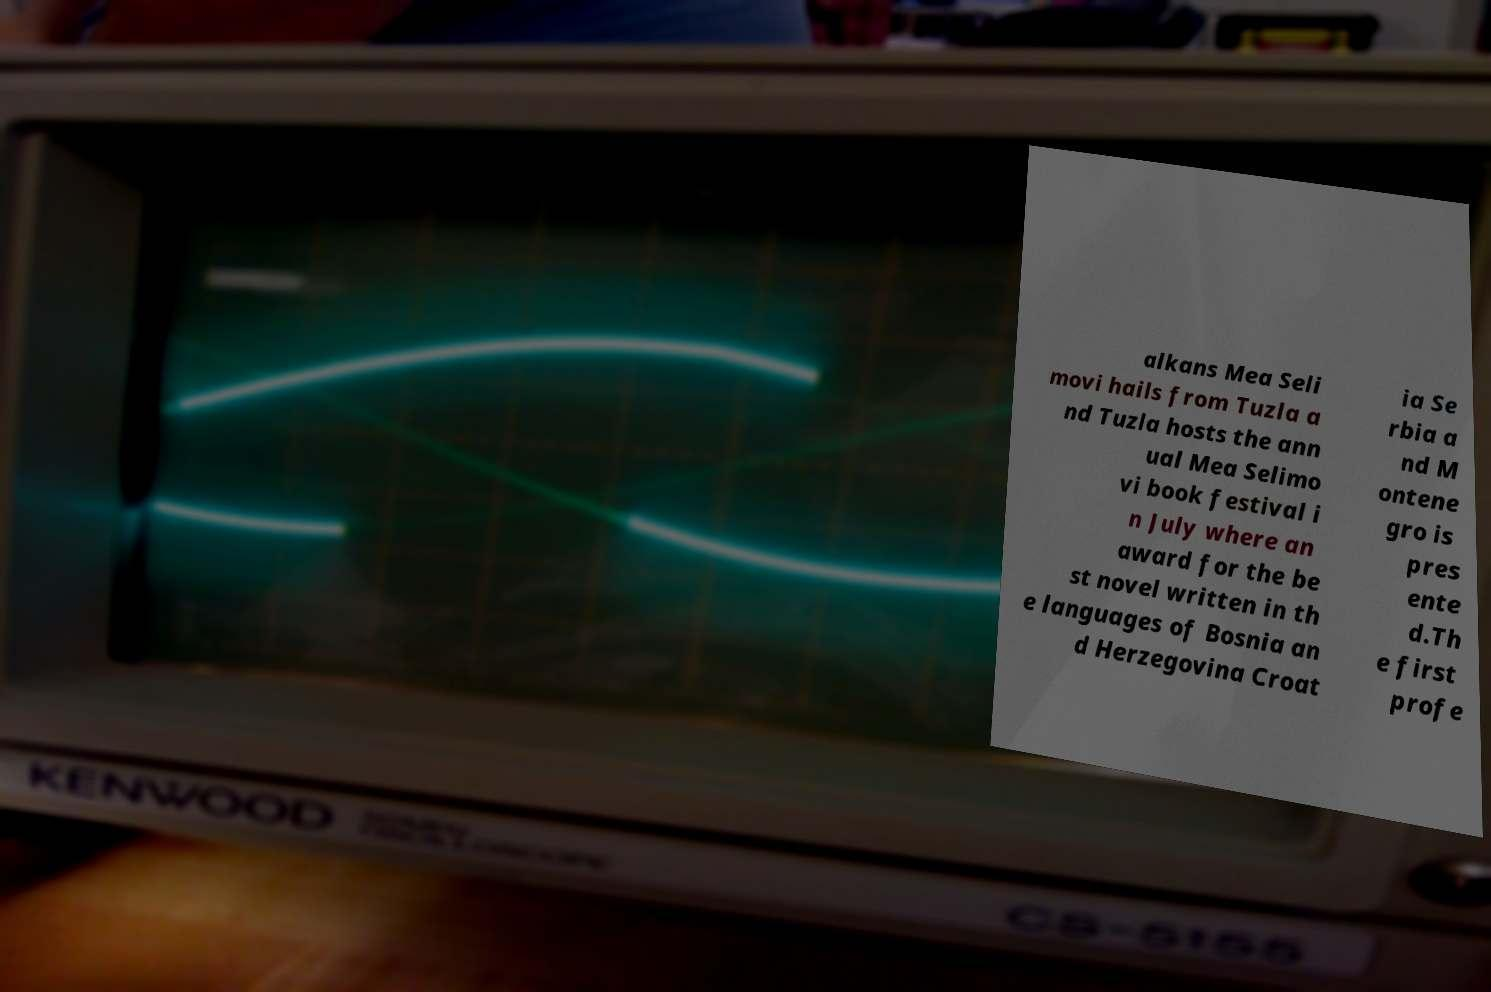Could you extract and type out the text from this image? alkans Mea Seli movi hails from Tuzla a nd Tuzla hosts the ann ual Mea Selimo vi book festival i n July where an award for the be st novel written in th e languages of Bosnia an d Herzegovina Croat ia Se rbia a nd M ontene gro is pres ente d.Th e first profe 